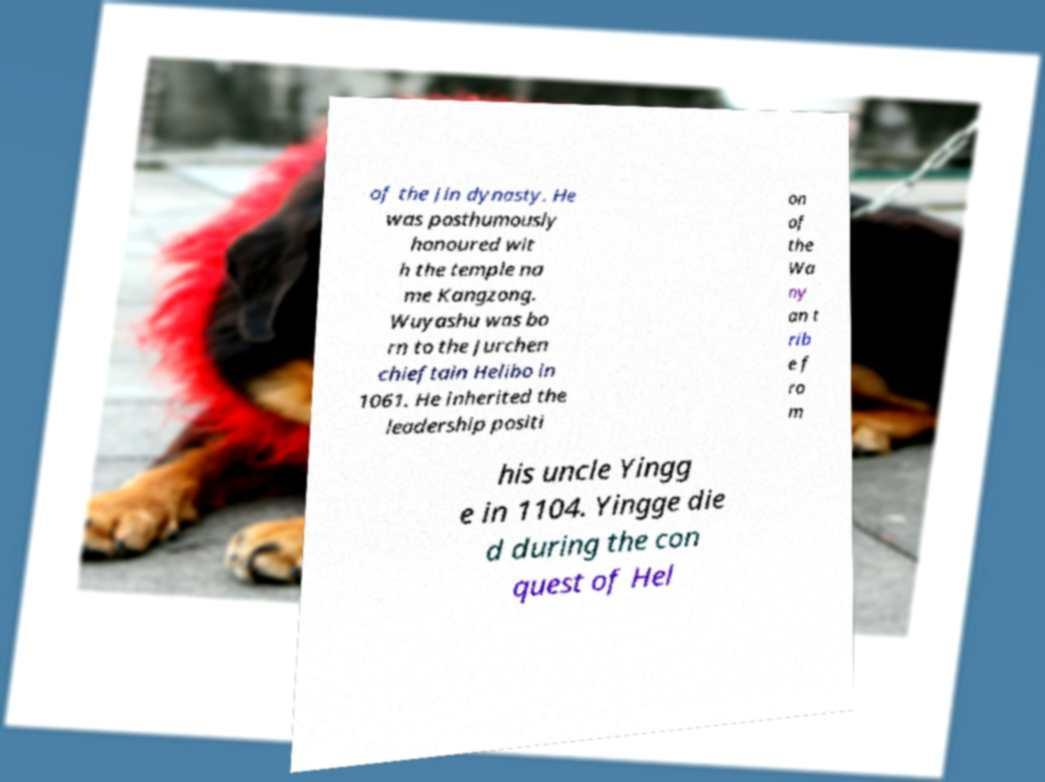I need the written content from this picture converted into text. Can you do that? of the Jin dynasty. He was posthumously honoured wit h the temple na me Kangzong. Wuyashu was bo rn to the Jurchen chieftain Helibo in 1061. He inherited the leadership positi on of the Wa ny an t rib e f ro m his uncle Yingg e in 1104. Yingge die d during the con quest of Hel 